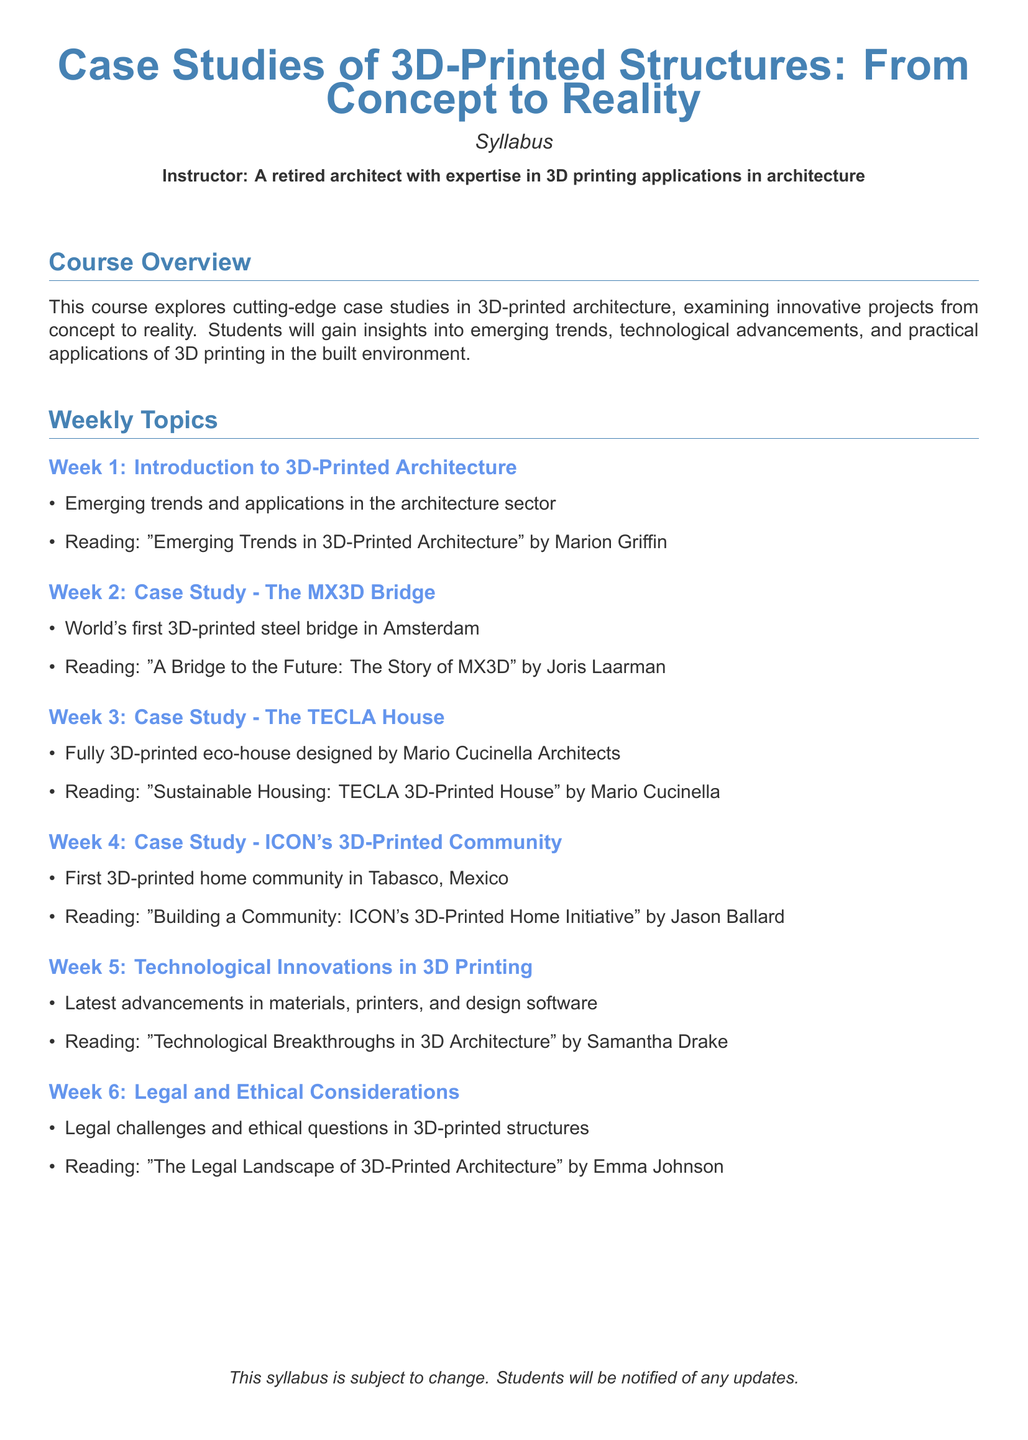What is the title of the syllabus? The title is stated at the top of the document.
Answer: Case Studies of 3D-Printed Structures: From Concept to Reality Who is the instructor for the course? The instructor's name is mentioned in the syllabus.
Answer: A retired architect with expertise in 3D printing applications in architecture What week covers the case study of the MX3D Bridge? Each week is numbered in the syllabus.
Answer: Week 2 Which reading is associated with the TECLA House case study? The reading for each case study is provided under the respective week.
Answer: Sustainable Housing: TECLA 3D-Printed House by Mario Cucinella What is the focus of Week 5 in the syllabus? The weekly topic is outlined clearly, focusing on technologies.
Answer: Technological Innovations in 3D Printing How many total weeks of topics are covered in the syllabus? The number of weeks is explicitly listed in the document.
Answer: Six What is the name of the first case study mentioned? The first case study is listed under Week 2.
Answer: The MX3D Bridge What type of considerations are discussed in Week 6? The topic is categorized clearly in the syllabus.
Answer: Legal and Ethical Considerations What is the reading author for the technological innovations topic? The reading reference includes the author's name indicated in Week 5.
Answer: Samantha Drake What notable feature does the ICON's community hold? This is found in the description of Week 4.
Answer: First 3D-printed home community 